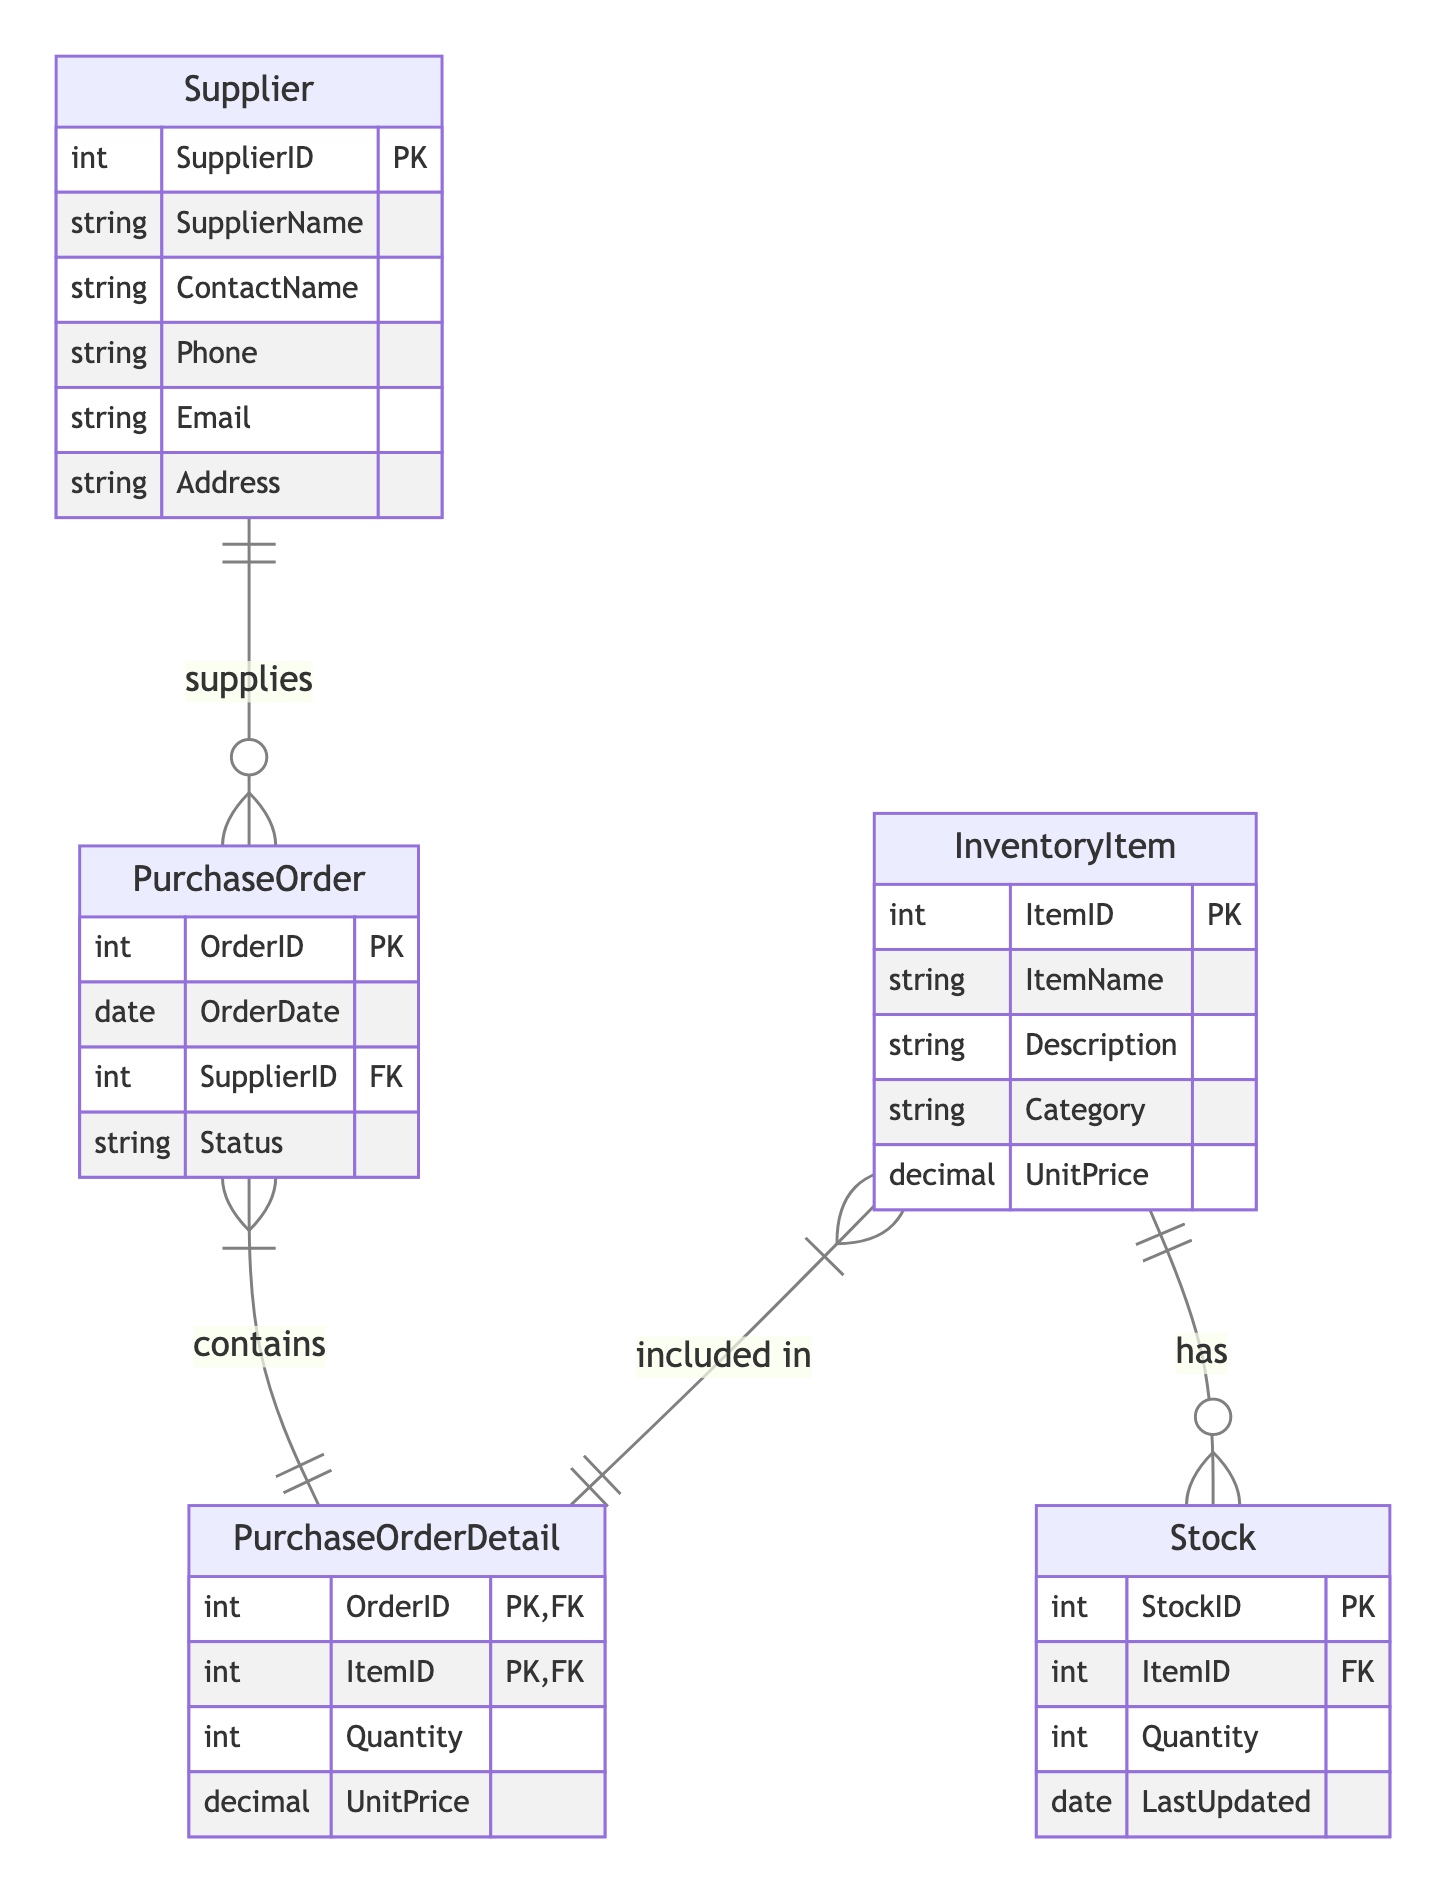What's the primary key of the InventoryItem entity? The InventoryItem entity has a primary key attribute called ItemID, which uniquely identifies each item in the inventory.
Answer: ItemID How many primary keys are there in the Supplier entity? The Supplier entity has one primary key attribute called SupplierID. This is the only key that uniquely identifies each supplier.
Answer: One What relationship exists between Supplier and PurchaseOrder? The relationship between Supplier and PurchaseOrder is a one-to-many relationship, meaning a single supplier can supply multiple purchase orders.
Answer: One-to-many Which entity directly links PurchaseOrder and InventoryItem? The PurchaseOrderDetail entity directly links PurchaseOrder and InventoryItem, as it contains instances of both with foreign keys from each entity.
Answer: PurchaseOrderDetail How many attributes does the Stock entity have? The Stock entity has four attributes: StockID, ItemID, Quantity, and LastUpdated.
Answer: Four What is the foreign key in the PurchaseOrder entity? The foreign key in the PurchaseOrder entity is SupplierID, which links to the Supplier entity to identify the supplier that fulfilled the order.
Answer: SupplierID Which entities have a one-to-many relationship? The entities that have a one-to-many relationship are Supplier and PurchaseOrder, as well as InventoryItem and Stock.
Answer: Supplier and PurchaseOrder, InventoryItem and Stock What is the main purpose of the PurchaseOrderDetail entity? The main purpose of the PurchaseOrderDetail entity is to connect PurchaseOrder with InventoryItem, indicating which items are included in each order and in what quantity.
Answer: Connect PurchaseOrder with InventoryItem What attribute in the Stock entity indicates the last time stock levels were updated? The attribute that indicates the last time stock levels were updated in the Stock entity is LastUpdated.
Answer: LastUpdated 